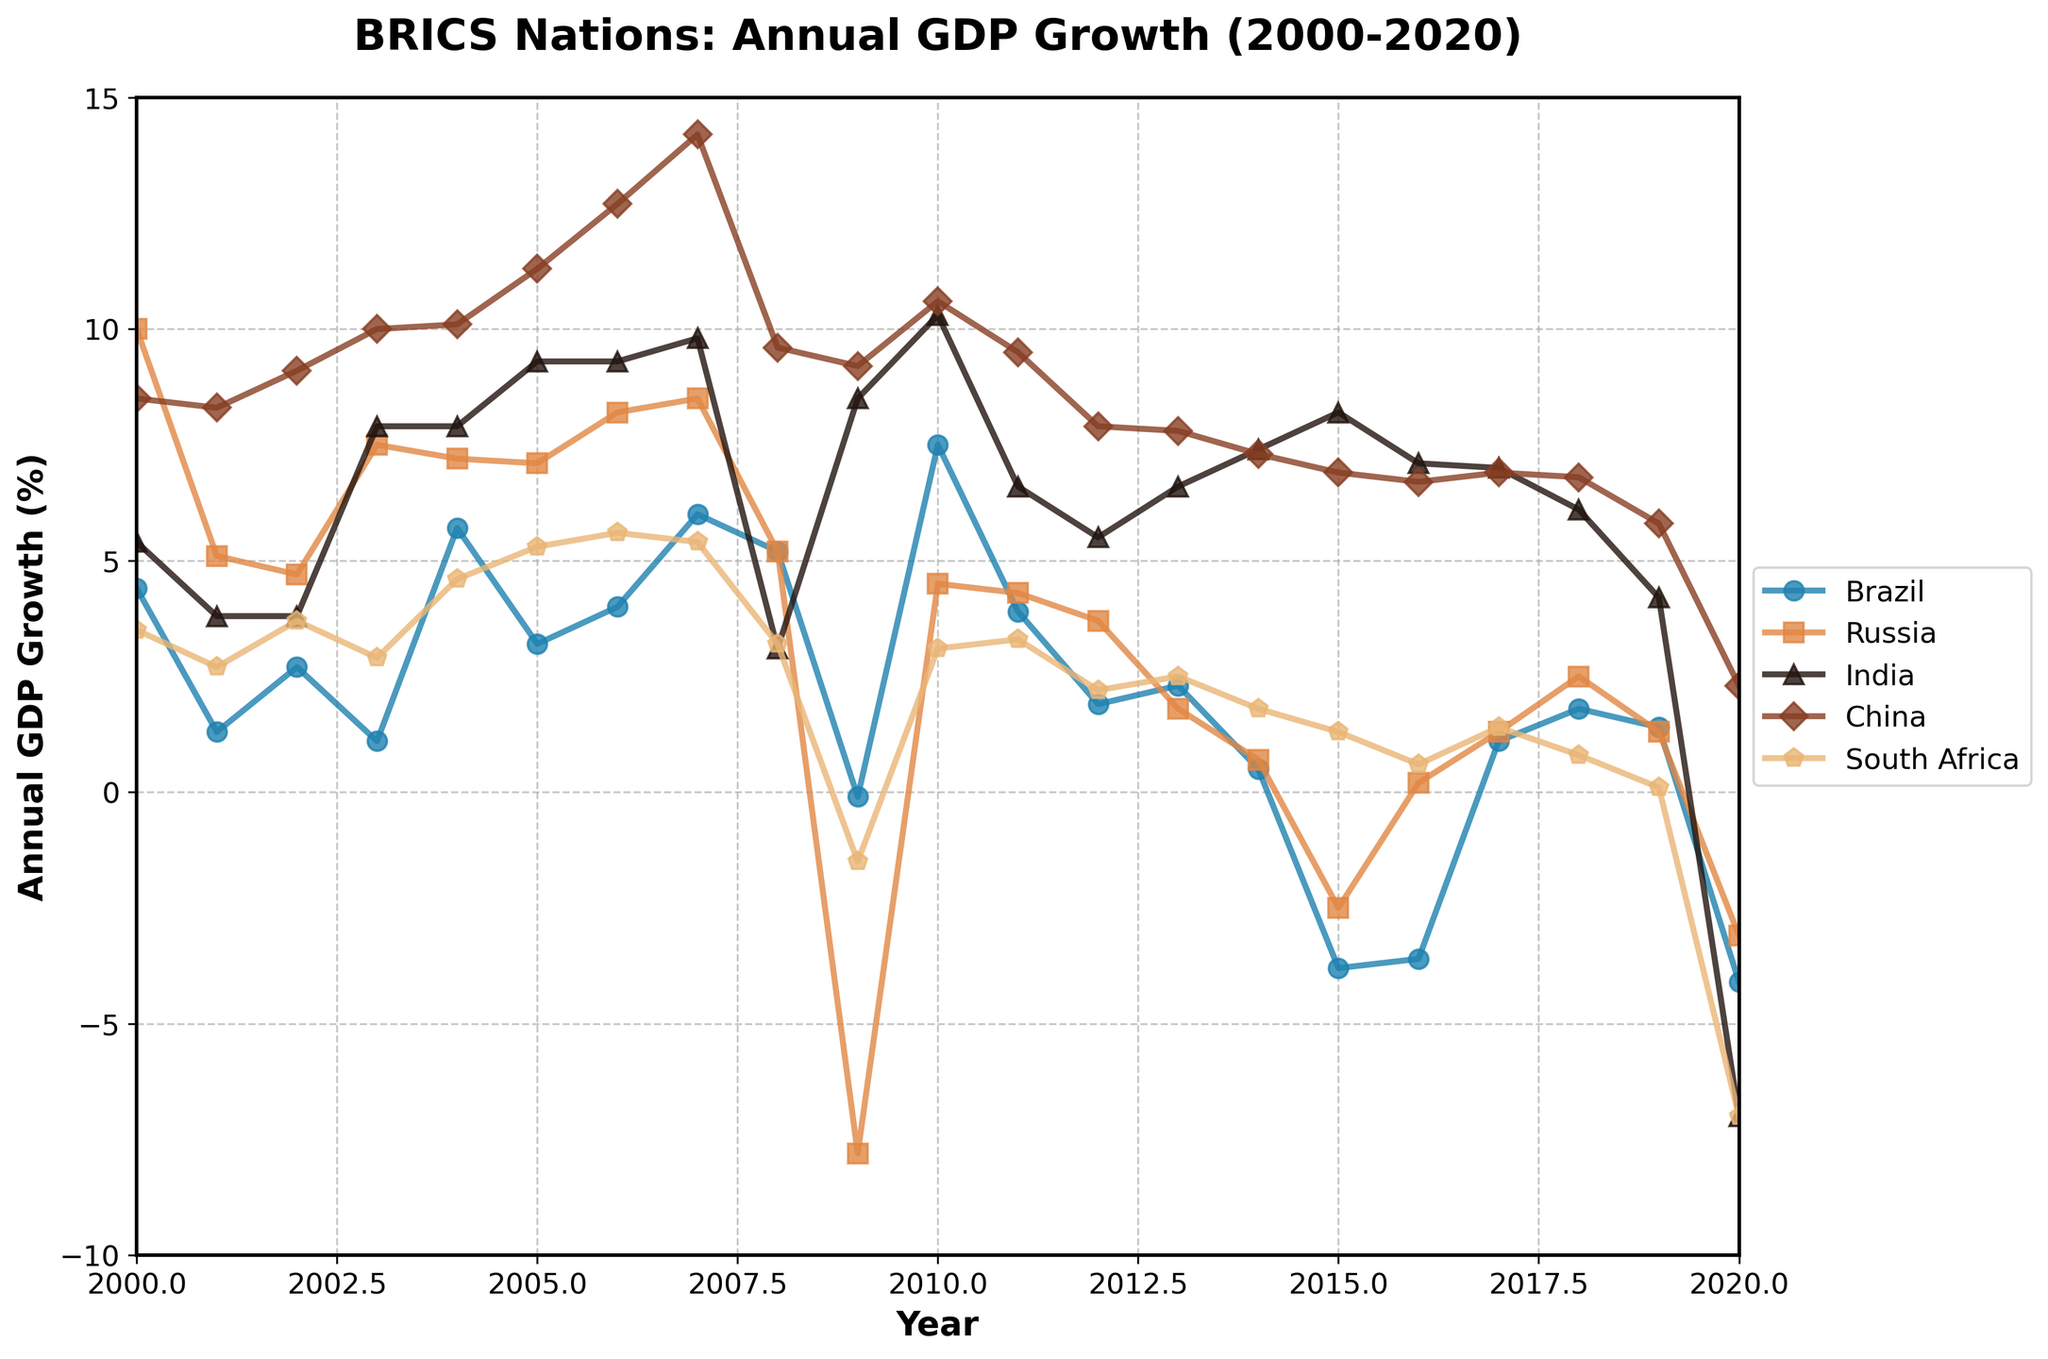what is the title of the plot? The title is displayed at the top of the plot, stating the purpose and the time range it covers.
Answer: BRICS Nations: Annual GDP Growth (2000-2020) Which country has the highest peak GDP growth and in what year? To find this, look at the highest point on each country's line. China has the highest peak visible at 14.2% in 2007.
Answer: China, 2007 Which country experienced the largest GDP decline and in what year? Check for the lowest points on each line. Russia saw the steepest decline at -7.8% in 2009.
Answer: Russia, 2009 What was India's GDP growth in 2020, and how does it compare to the previous year? Locate India's values for 2019 and 2020. India's GDP growth in 2020 was -7.0%, down from 4.2% in 2019. This is a decrease of 11.2 percentage points.
Answer: -7.0%; a decrease of 11.2 percentage points In which years did Brazil experience negative GDP growth? Identify the downward crossing over the 0% line for Brazil. Brazil had negative GDP growth in 2009, 2015, 2016, and 2020.
Answer: 2009, 2015, 2016, 2020 Between 2000 and 2020, which BRICS nation had the most consistent GDP growth? Examine the stability of each country's line. China's line is the most consistent, staying mostly high with gradual changes.
Answer: China How did South Africa's GDP growth change from 2014 to 2016? Look for the trend in South Africa's data points from 2014 to 2016. South Africa experienced a decline from 1.8% in 2014 to 1.3% in 2015 and then further down to 0.6% in 2016.
Answer: Declined from 1.8% to 0.6% Which two countries had positive GDP growth during the global financial crisis in 2008? Check the values in 2008 for all countries. China and India sustained positive growth during 2008 (9.6% and 3.1%, respectively).
Answer: China and India What is the average GDP growth for Russia between 2000 and 2020? Calculate the arithmetic mean of Russia's annual GDP growth values over this period. Summing Russia's values: 10 + 5.1 + 4.7 + 7.5 + 7.2 + 7.1 + 8.2 + 8.5 + 5.2 - 7.8 + 4.5 + 4.3 + 3.7 + 1.8 + 0.7 - 2.5 + 0.2 + 1.3 + 2.5 + 1.3 - 3.1 = 71.6. Dividing by 21 years gives an average of approximately 3.41%.
Answer: Approximately 3.41% List the years in which Brazil had higher GDP growth than South Africa. Compare yearly data points between Brazil and South Africa. Brazil's GDP growth was higher in: 2000, 2001, 2002, 2004, 2005, 2007, 2009, 2010, 2017, and 2018.
Answer: 2000, 2001, 2002, 2004, 2005, 2007, 2009, 2010, 2017, 2018 